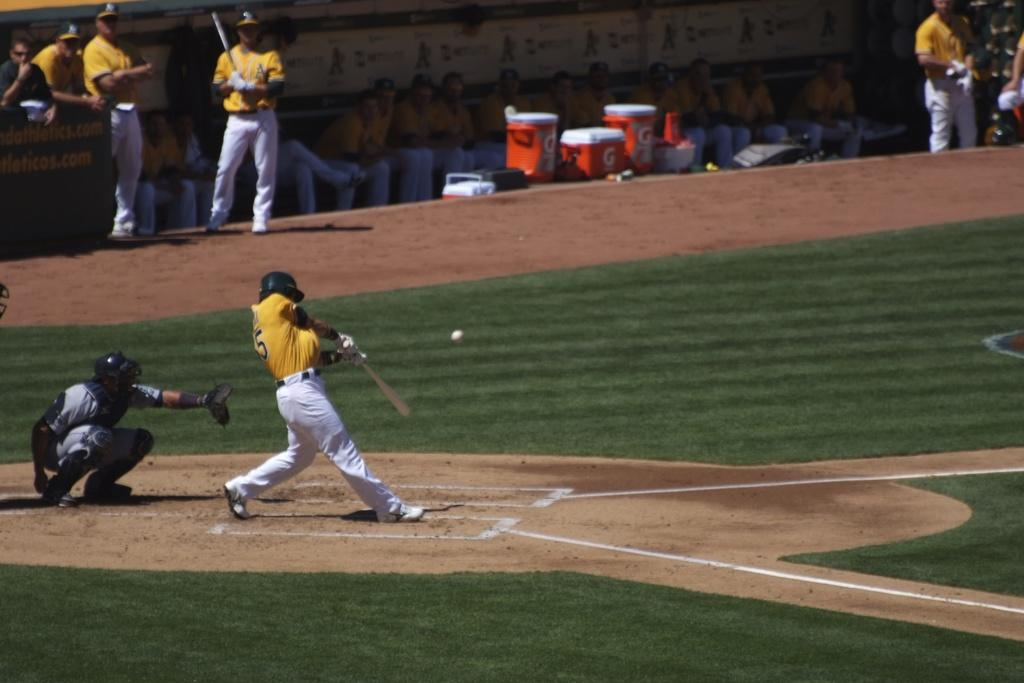How many people are in the image? There are people in the image, but the exact number is not specified. What are the people in the image doing? Some people are sitting, while others are standing. What objects are people holding in the image? Some people are holding bats. What can be seen on the ground in the image? There are objects on the ground. What type of sweater is the person wearing in the image? There is no mention of a sweater or any clothing in the image. Can you tell me how many notebooks are on the ground in the image? There is no mention of notebooks or any specific objects on the ground in the image. 